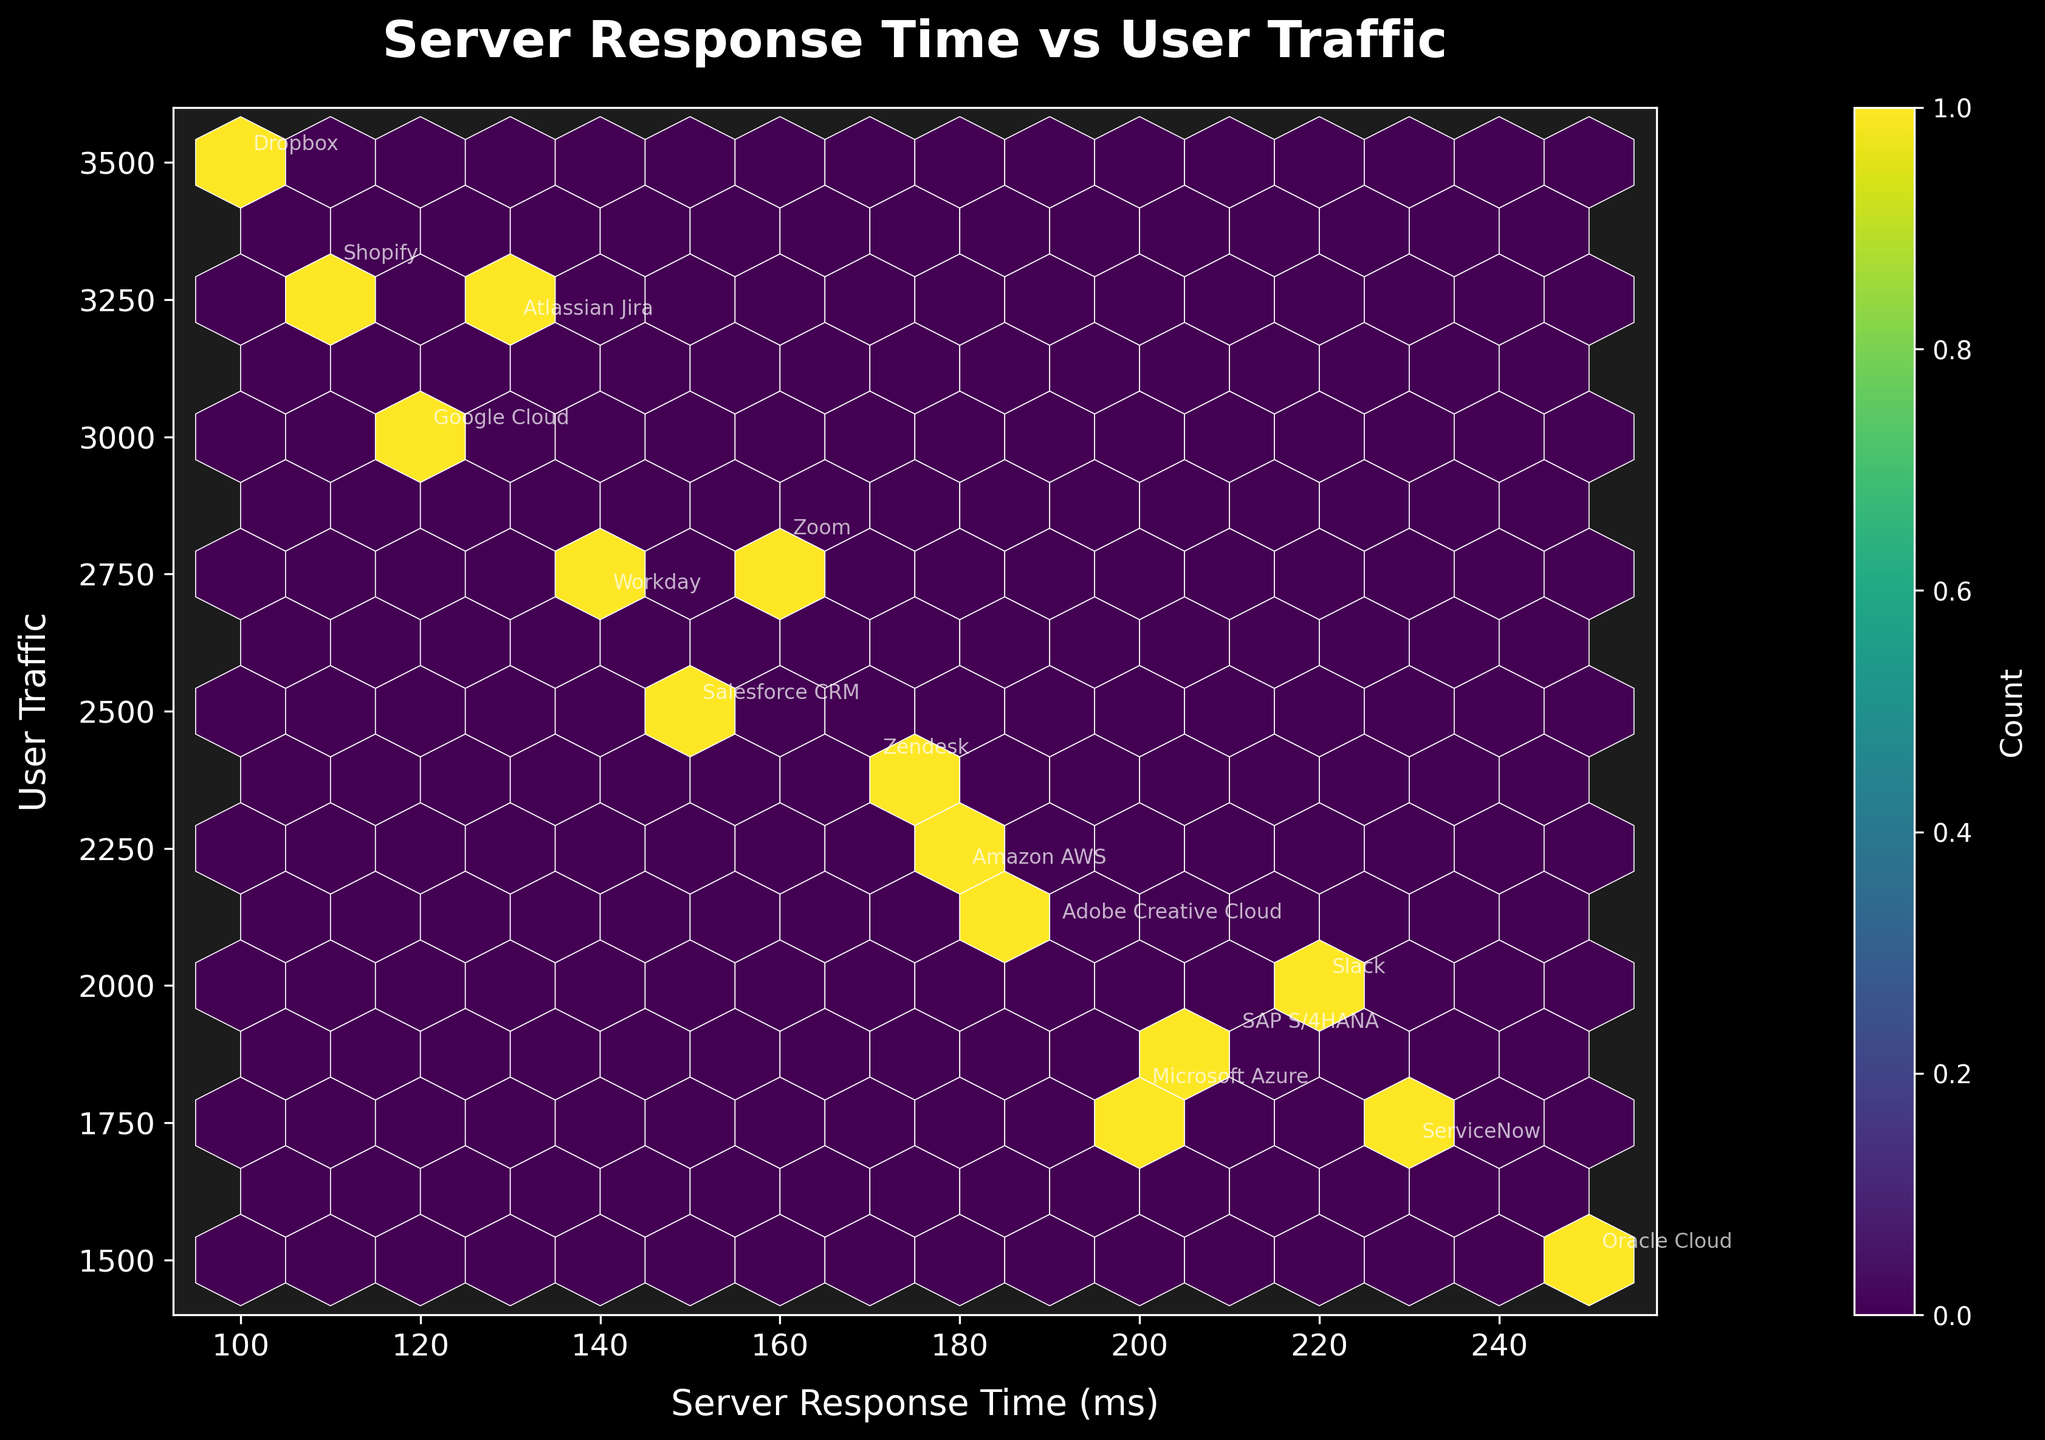What's the title of the plot? The title is located at the top of the plot in a larger, bold font.
Answer: Server Response Time vs User Traffic How many data points are shown in the plot? Each application name annotated on the plot corresponds to one data point. Thus, counting the annotations gives the number of data points. There are 15 application names.
Answer: 15 What's the range of server response times covered in the plot? By looking at the x-axis, we can see the lowest and highest values of server response times. The server response times range from around 100 ms to 250 ms.
Answer: 100 ms to 250 ms Which application has the highest user traffic? By looking at the y-axis values annotated with application names, we can identify the application that aligns with the highest user traffic value.
Answer: Dropbox Does user traffic generally increase or decrease with server response time? By observing the overall distribution and the density in the hexbin plot, we can see if there is a trend of user traffic increasing or decreasing as server response times change. The plot shows no strong increasing or decreasing trend; the distribution appears spread.
Answer: No strong trend What is the user traffic for Shopify, and how does it compare to Zoom's user traffic? Locate the annotations for Shopify and Zoom, then read the corresponding user traffic values on the y-axis. Shopify has 3300, and Zoom has 2800. Compare the two values to see which is higher.
Answer: Shopify: 3300, Zoom: 2800 Which application has a response time of 200 ms, and how much user traffic does it have? Find the point where the data values (x-axis for response time and y-axis for user traffic) intersect at 200 ms. The annotation to this point shows the application is Microsoft Azure, with a user traffic of 1800.
Answer: Microsoft Azure, 1800 Which application has the lowest server response time, and what is its corresponding user traffic? Locate the point on the x-axis with the smallest value and read the corresponding annotation. The lowest server response time is 100 ms, which corresponds to Dropbox with 3500 user traffic.
Answer: Dropbox, 3500 What's the user traffic for the application with a server response time of 220 ms? Locate the data point where the server response time is 220 ms and read its y-axis value. The application is Slack, and the user traffic is 2000.
Answer: 2000 Is there any application with a server response time above 240 ms? If so, name it. Check the x-axis for any points above 240 ms and identify the corresponding application. Oracle Cloud and ServiceNow fall above this threshold.
Answer: Oracle Cloud, ServiceNow 